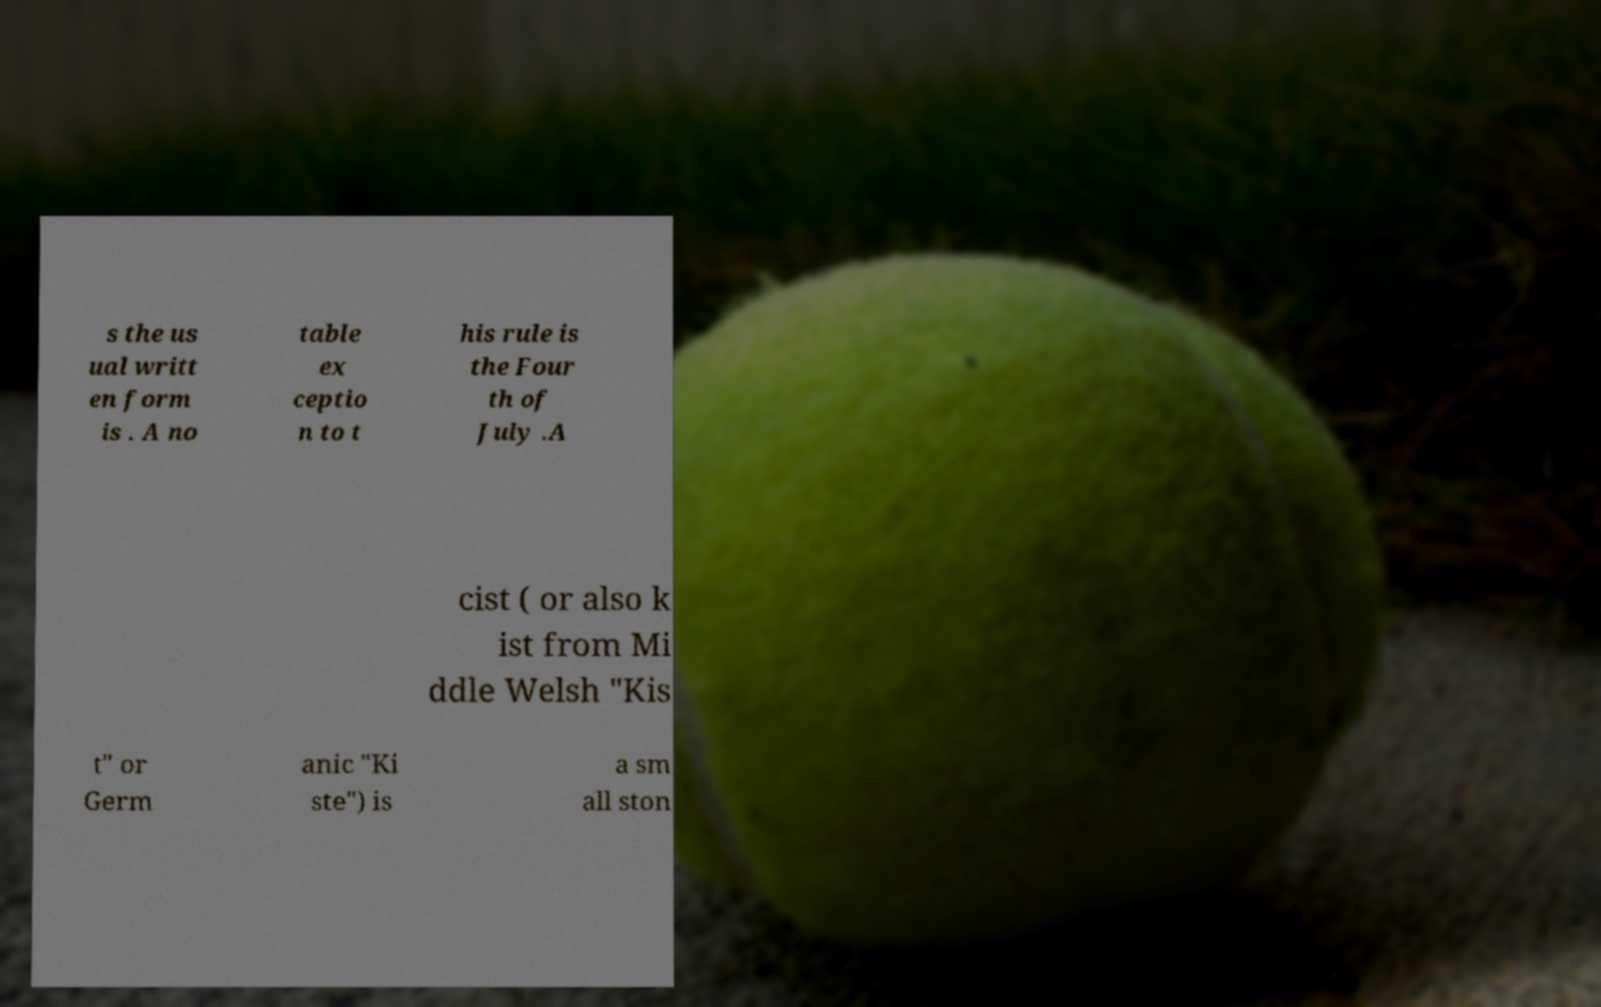Please identify and transcribe the text found in this image. s the us ual writt en form is . A no table ex ceptio n to t his rule is the Four th of July .A cist ( or also k ist from Mi ddle Welsh "Kis t" or Germ anic "Ki ste") is a sm all ston 